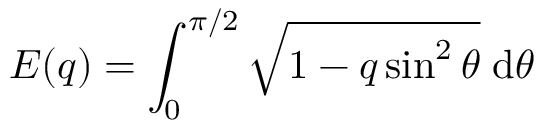Convert formula to latex. <formula><loc_0><loc_0><loc_500><loc_500>E ( q ) = \int _ { 0 } ^ { \pi / 2 } \sqrt { 1 - q \sin ^ { 2 } { \theta } } \, d \theta</formula> 